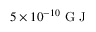Convert formula to latex. <formula><loc_0><loc_0><loc_500><loc_500>5 \times 1 0 ^ { - 1 0 } G J</formula> 